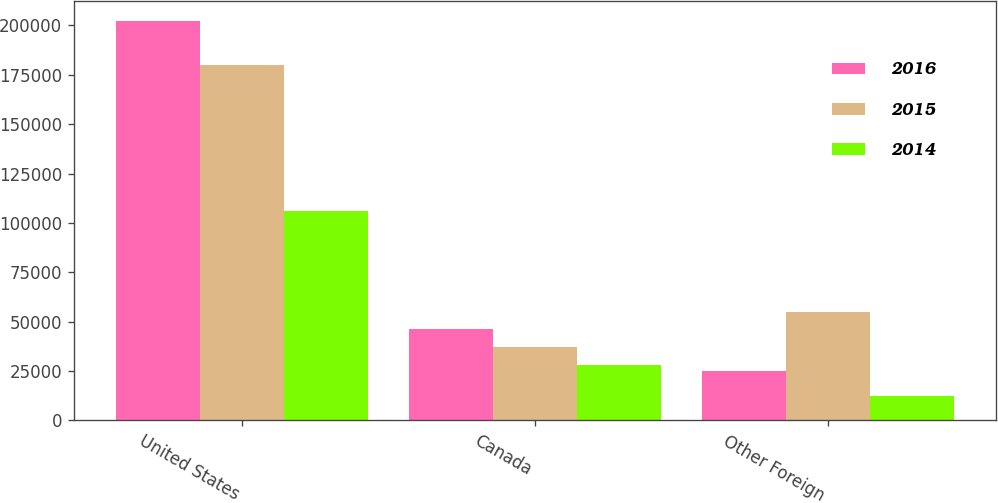Convert chart. <chart><loc_0><loc_0><loc_500><loc_500><stacked_bar_chart><ecel><fcel>United States<fcel>Canada<fcel>Other Foreign<nl><fcel>2016<fcel>202067<fcel>46191<fcel>24885<nl><fcel>2015<fcel>179928<fcel>37131<fcel>54993<nl><fcel>2014<fcel>106223<fcel>28157<fcel>12264<nl></chart> 